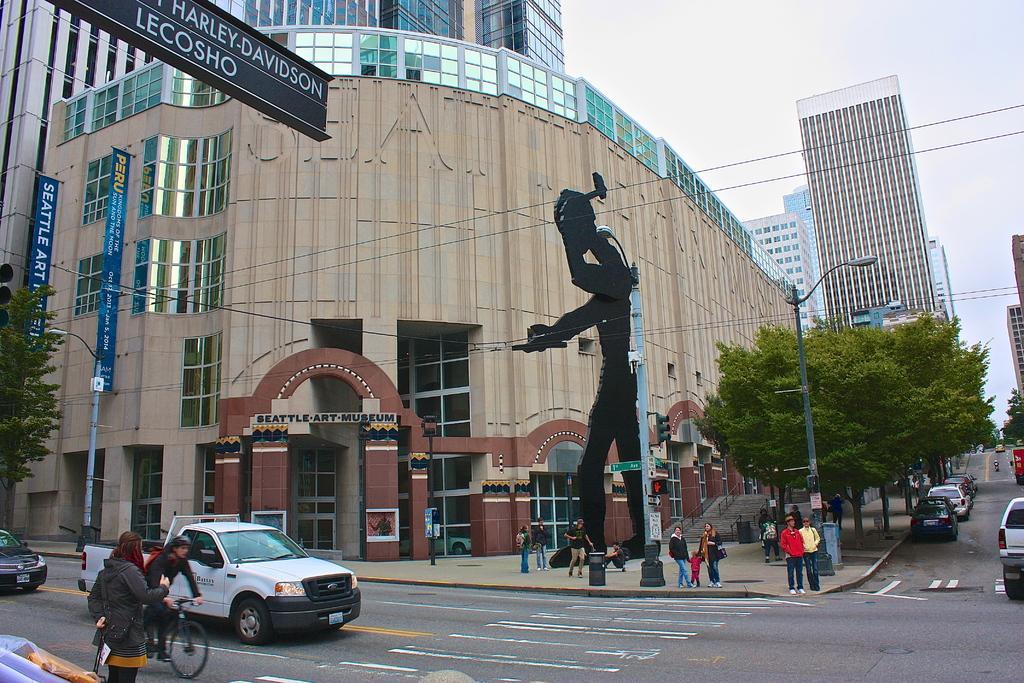How would you summarize this image in a sentence or two? In this picture we can see a person riding a bicycle, vehicles on the road, name boards, banners, trees, poles, buildings, some objects, some people are standing on the footpath and in the background we can see the sky. 